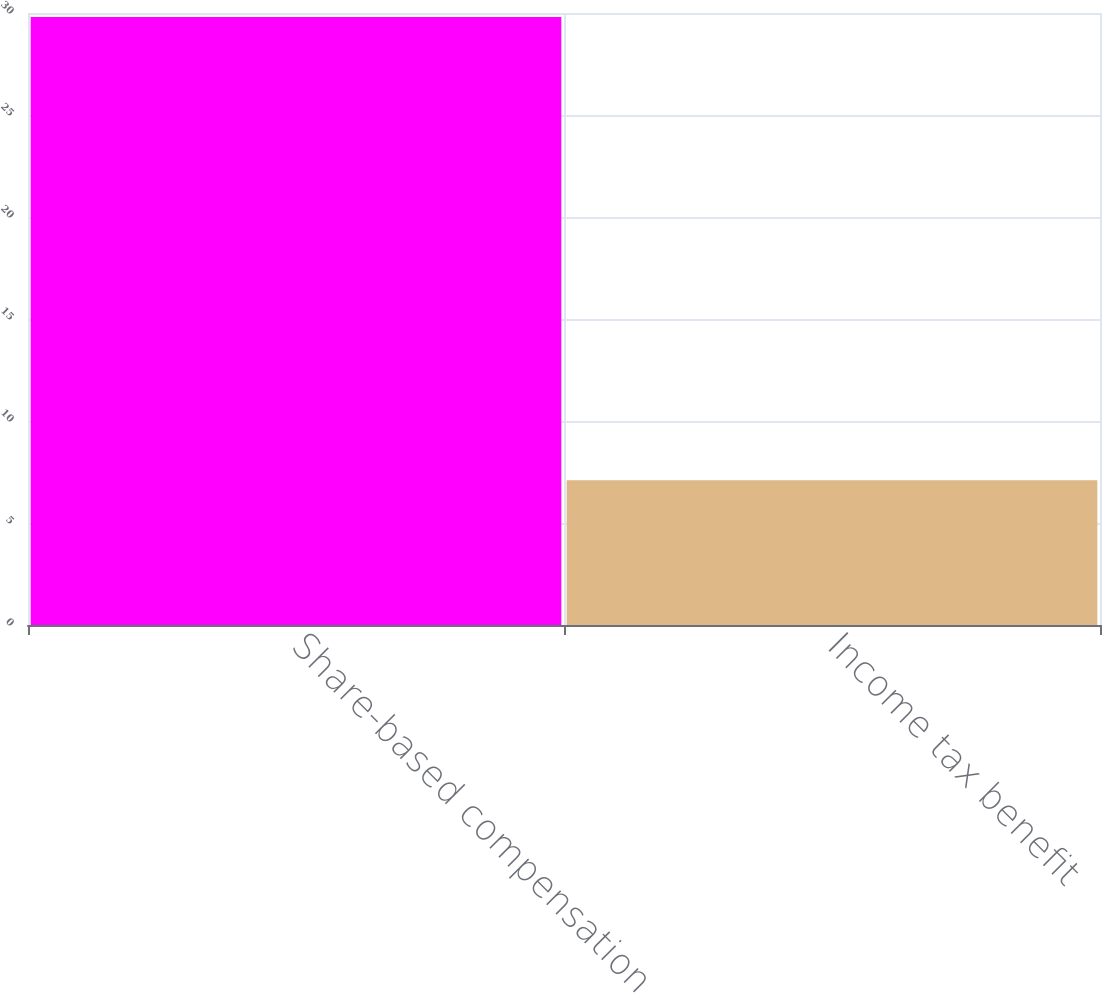Convert chart. <chart><loc_0><loc_0><loc_500><loc_500><bar_chart><fcel>Share-based compensation<fcel>Income tax benefit<nl><fcel>29.8<fcel>7.1<nl></chart> 